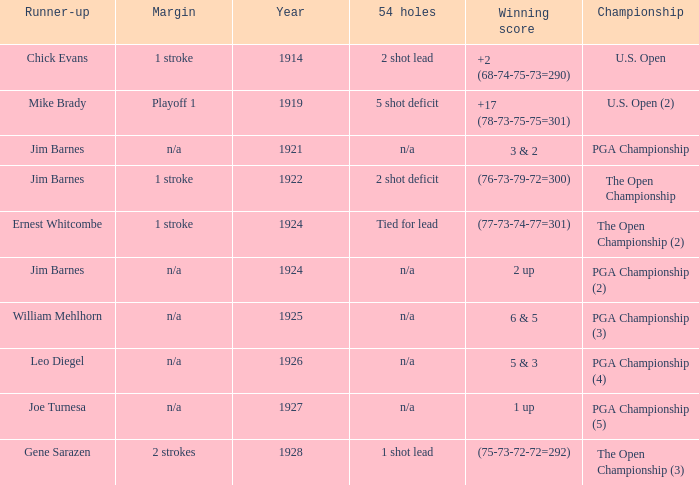WHAT WAS THE YEAR WHEN THE RUNNER-UP WAS WILLIAM MEHLHORN? 1925.0. 